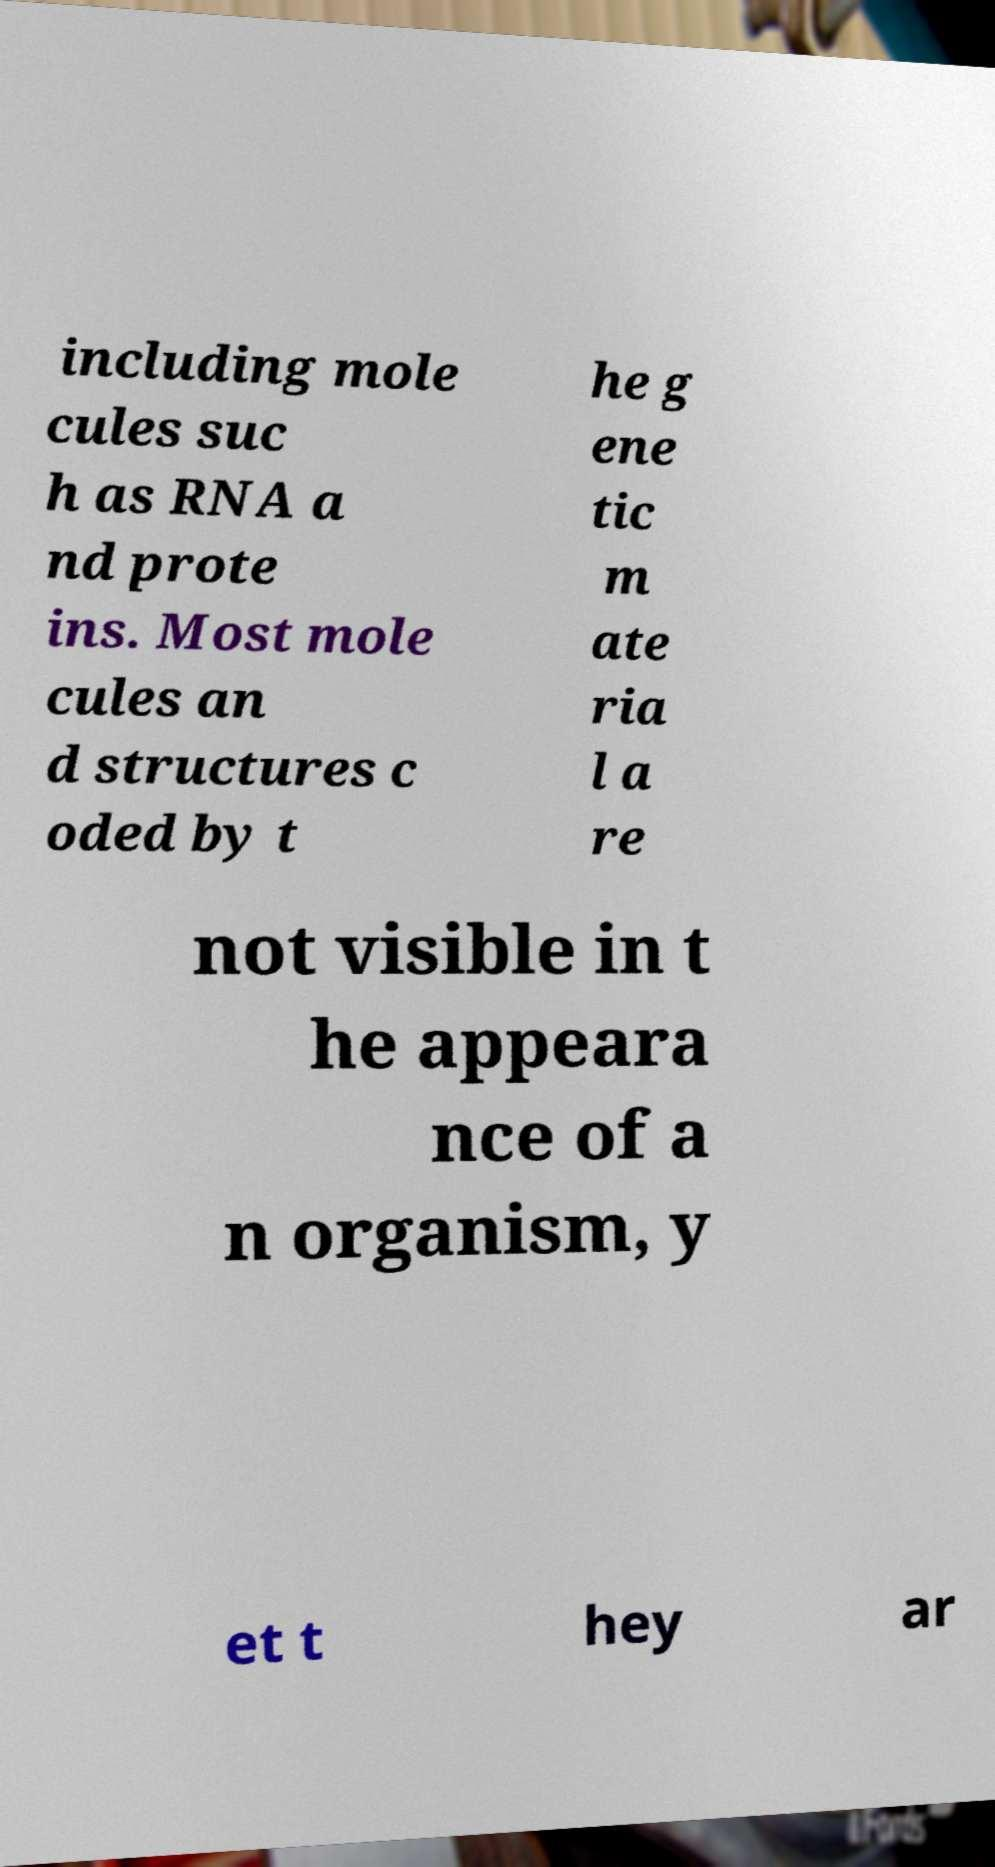Could you extract and type out the text from this image? including mole cules suc h as RNA a nd prote ins. Most mole cules an d structures c oded by t he g ene tic m ate ria l a re not visible in t he appeara nce of a n organism, y et t hey ar 